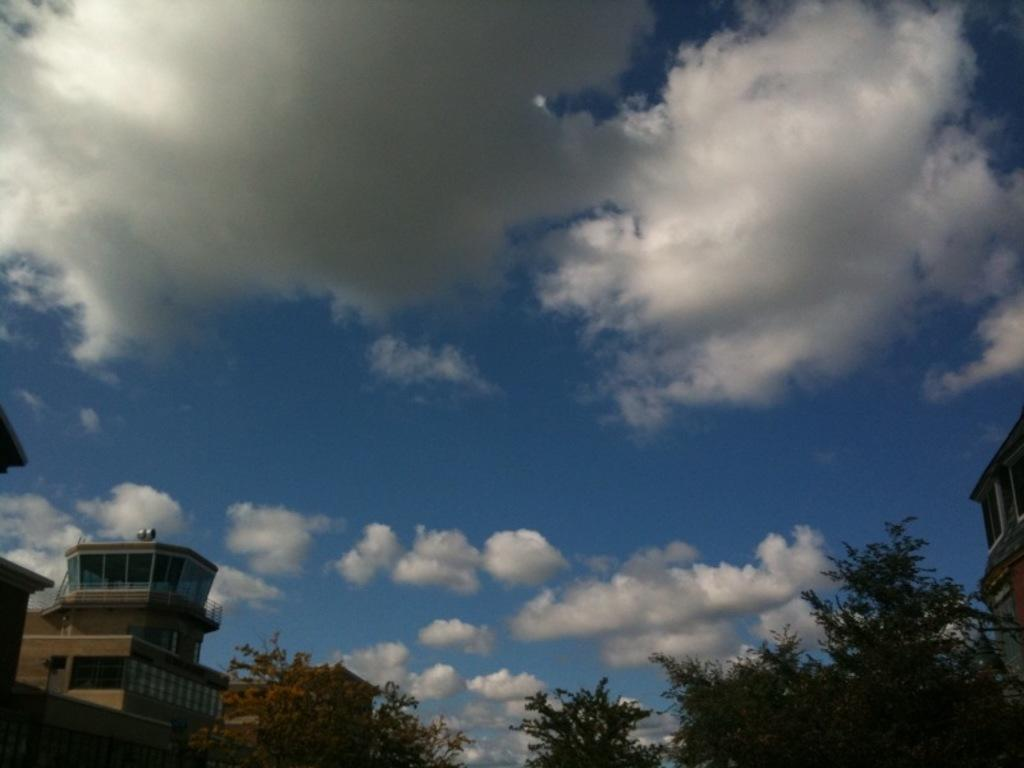What is the condition of the sky in the image? The sky is cloudy in the image. What type of structures can be seen in the image? There are buildings in the image. What other natural elements are present in the image? There are trees in the image. What feature do the buildings have? The buildings have windows. Can you see a flock of machines flying in the cloudy sky in the image? There are no machines or flocks of machines present in the image; it features buildings, trees, and a cloudy sky. 